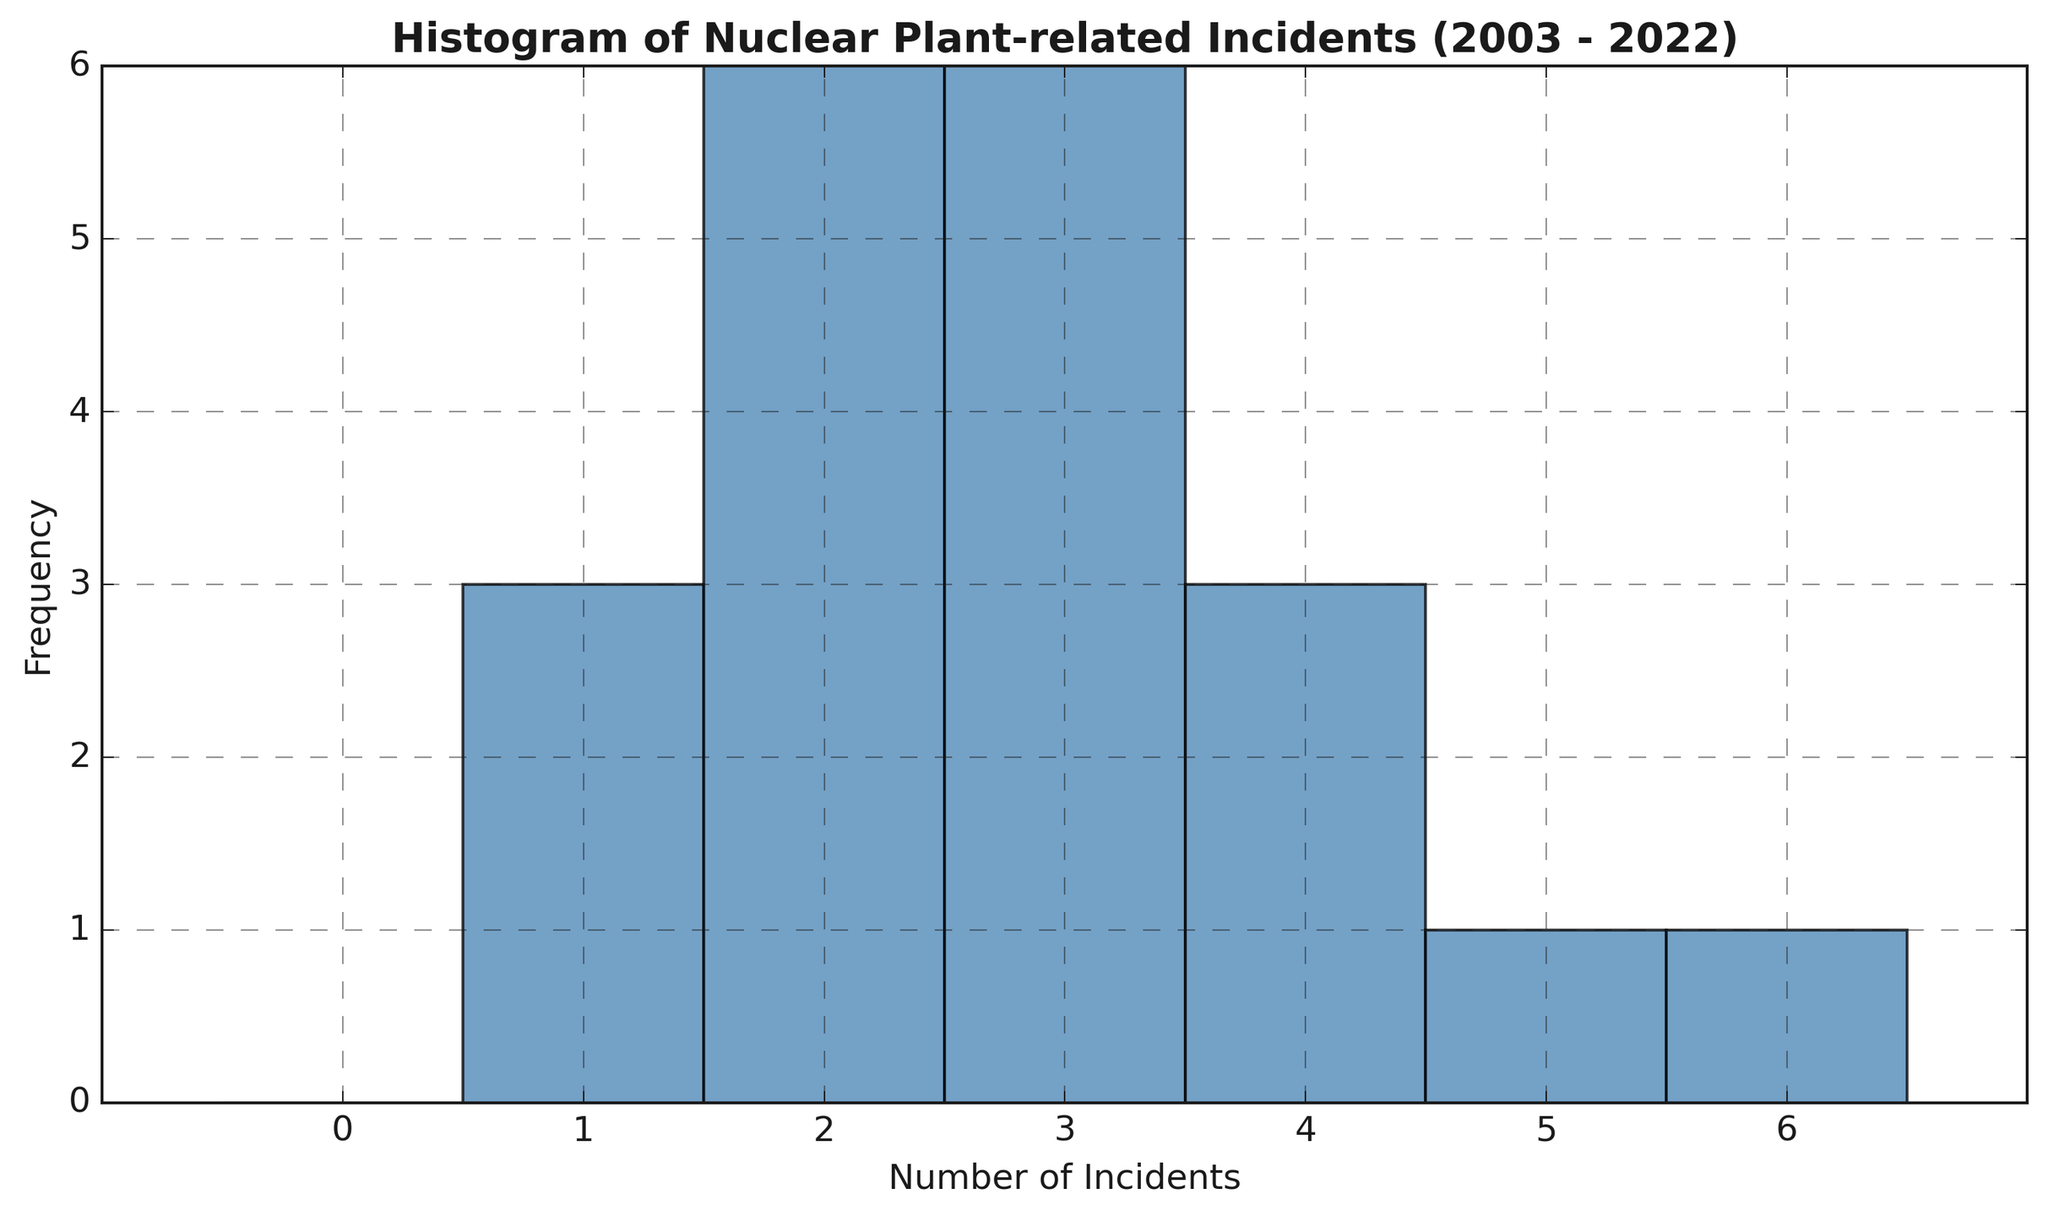What's the most frequent number of incidents reported in a year? The histogram shows the frequency of different numbers of incidents. By observing the tallest bar, we can identify the number of incidents with the highest frequency.
Answer: 3 Which number of incidents occurred the least frequently? To find the least frequent number of incidents, look at the shortest bars in the histogram. Identify the number of incidents corresponding to these bars.
Answer: 6 How many years had exactly three incidents? Count the number of bars corresponding to three incidents. The histogram indicates the frequency through the height of the bars. The bar for three incidents has a frequency of 6.
Answer: 6 What are the years with the highest number of incidents? The bars in the histogram show the different numbers of incidents. The highest bar corresponds to six incidents. Checking the data, the year with six incidents is 2011.
Answer: 2011 How many years had an above-average number of incidents? First, calculate the average number of incidents. Sum all incidents and divide by the number of years: (3+2+4+2+3+1+5+4+6+2+3+1+4+2+3+1+2+3+2+3)/20 = 3. To count above-average years, check for years with incidents greater than 3: 2005 (4), 2009 (5), 2010 (4), 2011 (6), 2015 (4).
Answer: 5 What is the median number of incidents per year? To find the median, sort the values and find the middle one. Sorting incidents: 1, 1, 1, 1, 2, 2, 2, 2, 2, 3, 3, 3, 3, 3, 3, 4, 4, 4, 4, 5, 6. The middle number (11th value) is 3.
Answer: 3 How does the frequency of years with two incidents compare to years with four incidents? Compare the heights of the bars for two and four incidents. Years with two incidents are more frequent: frequency for two incidents is 6; frequency for four incidents is 4.
Answer: Years with two incidents are more frequent What is the range of the number of incidents reported annually? The range is the difference between the maximum and minimum numbers of incidents. The histogram indicates these values: maximum is 6, minimum is 1. The range is 6-1=5.
Answer: 5 How often did an incident count of one occur compared to five? Compare the heights of the bars for one incident and five incidents. The frequency for one incident is 3, and for five incidents it is 1.
Answer: One incident occurred more often than five incidents How many years had three or fewer incidents? Count the bars for the numbers ≤ 3 in the histogram: one incident (3 years), two incidents (6 years), three incidents (6 years). Total years: 3+6+6=15.
Answer: 15 